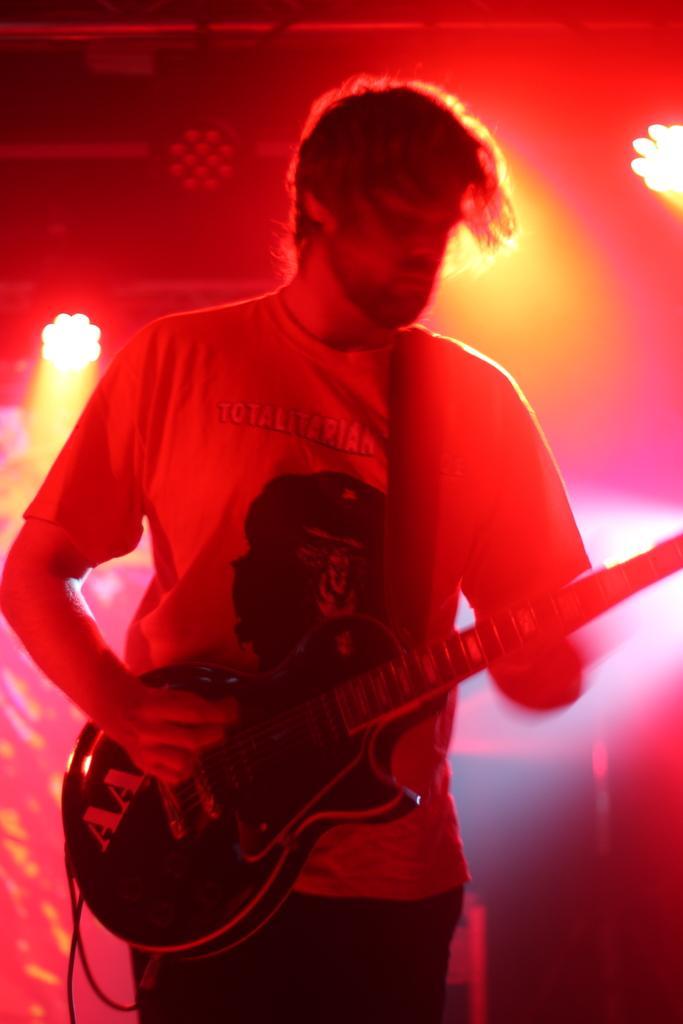Can you describe this image briefly? In this picture we can see a person,he is holding a guitar and in the background we can see lights,some objects. 